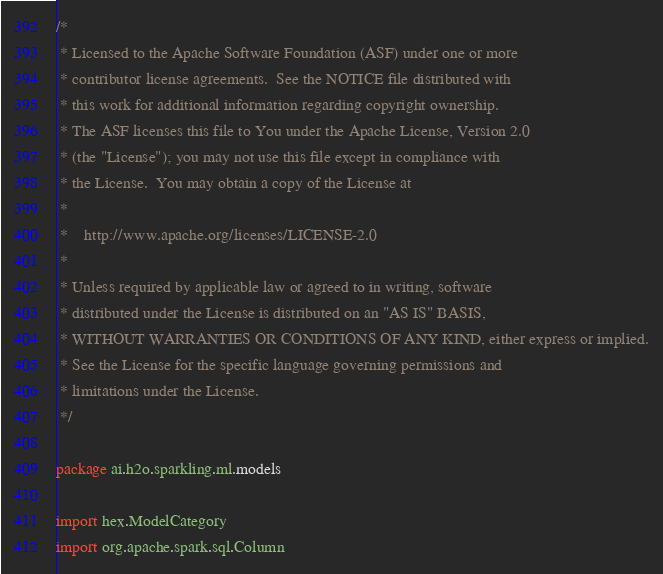Convert code to text. <code><loc_0><loc_0><loc_500><loc_500><_Scala_>/*
 * Licensed to the Apache Software Foundation (ASF) under one or more
 * contributor license agreements.  See the NOTICE file distributed with
 * this work for additional information regarding copyright ownership.
 * The ASF licenses this file to You under the Apache License, Version 2.0
 * (the "License"); you may not use this file except in compliance with
 * the License.  You may obtain a copy of the License at
 *
 *    http://www.apache.org/licenses/LICENSE-2.0
 *
 * Unless required by applicable law or agreed to in writing, software
 * distributed under the License is distributed on an "AS IS" BASIS,
 * WITHOUT WARRANTIES OR CONDITIONS OF ANY KIND, either express or implied.
 * See the License for the specific language governing permissions and
 * limitations under the License.
 */

package ai.h2o.sparkling.ml.models

import hex.ModelCategory
import org.apache.spark.sql.Column</code> 